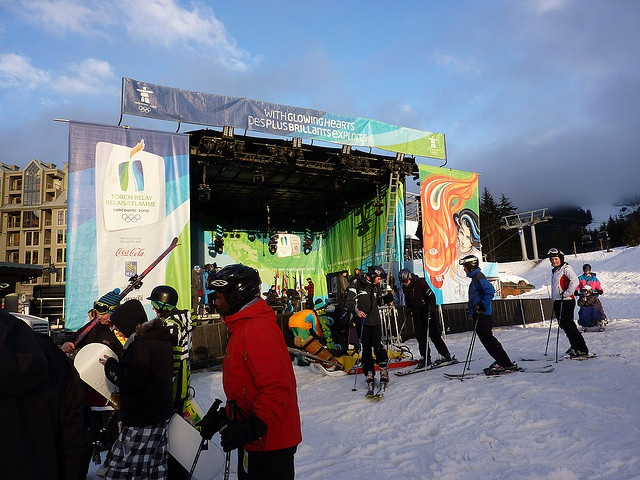Describe the objects in this image and their specific colors. I can see people in darkgray, black, maroon, and gray tones, people in darkgray, black, and gray tones, people in darkgray, black, gray, and darkgreen tones, snowboard in darkgray, gray, tan, and black tones, and people in darkgray, black, gray, and maroon tones in this image. 